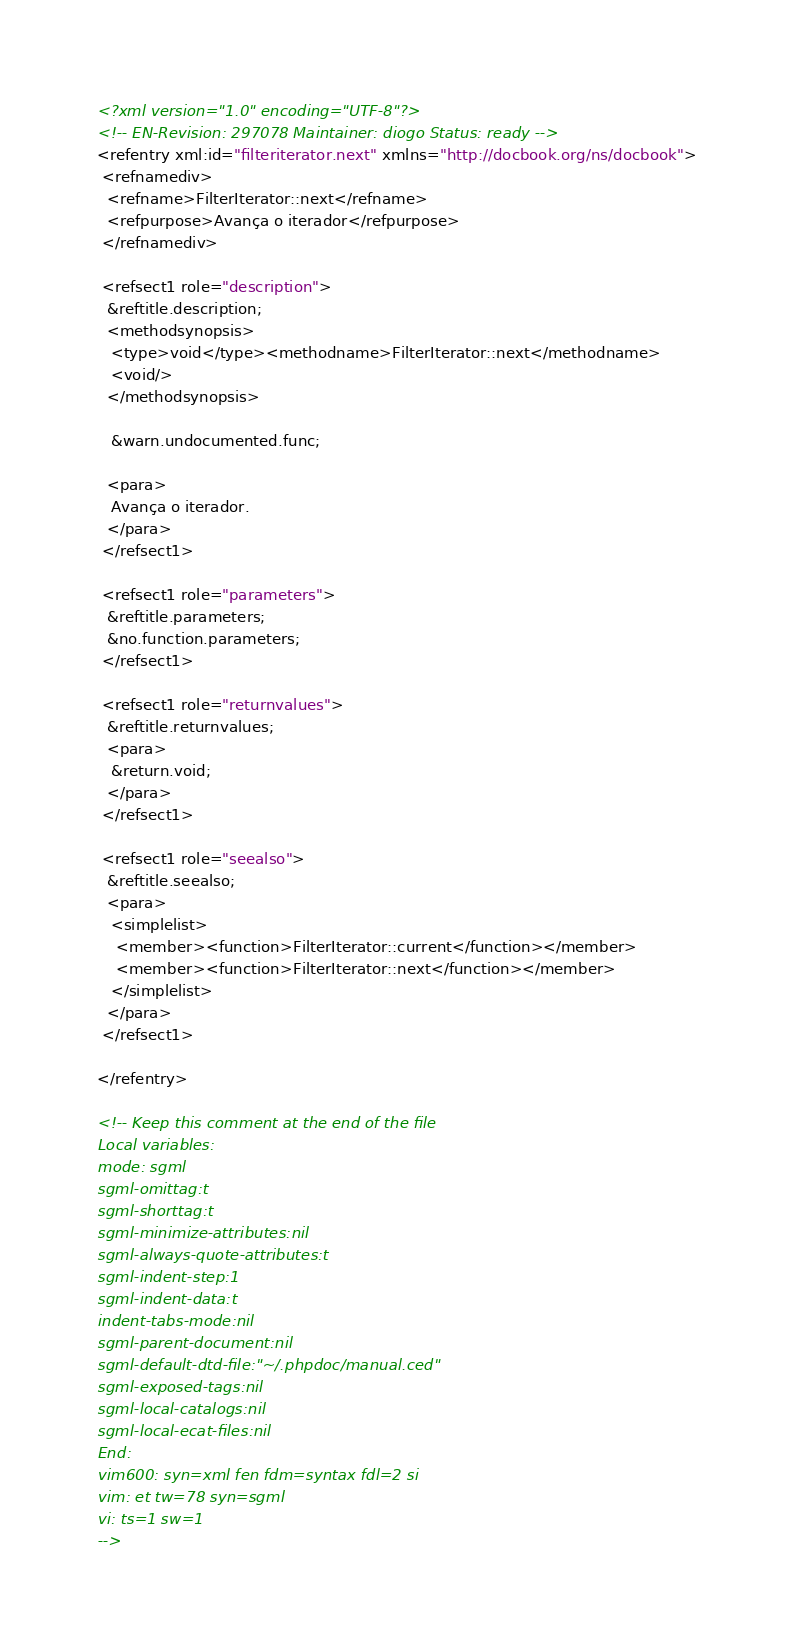Convert code to text. <code><loc_0><loc_0><loc_500><loc_500><_XML_><?xml version="1.0" encoding="UTF-8"?>
<!-- EN-Revision: 297078 Maintainer: diogo Status: ready -->
<refentry xml:id="filteriterator.next" xmlns="http://docbook.org/ns/docbook">
 <refnamediv>
  <refname>FilterIterator::next</refname>
  <refpurpose>Avança o iterador</refpurpose>
 </refnamediv>

 <refsect1 role="description">
  &reftitle.description;
  <methodsynopsis>
   <type>void</type><methodname>FilterIterator::next</methodname>
   <void/>
  </methodsynopsis>

   &warn.undocumented.func;

  <para>
   Avança o iterador.
  </para>
 </refsect1>

 <refsect1 role="parameters">
  &reftitle.parameters;
  &no.function.parameters;
 </refsect1>

 <refsect1 role="returnvalues">
  &reftitle.returnvalues;
  <para>
   &return.void;
  </para>
 </refsect1>

 <refsect1 role="seealso">
  &reftitle.seealso;
  <para>
   <simplelist>
    <member><function>FilterIterator::current</function></member>
    <member><function>FilterIterator::next</function></member>
   </simplelist>
  </para>
 </refsect1>

</refentry>

<!-- Keep this comment at the end of the file
Local variables:
mode: sgml
sgml-omittag:t
sgml-shorttag:t
sgml-minimize-attributes:nil
sgml-always-quote-attributes:t
sgml-indent-step:1
sgml-indent-data:t
indent-tabs-mode:nil
sgml-parent-document:nil
sgml-default-dtd-file:"~/.phpdoc/manual.ced"
sgml-exposed-tags:nil
sgml-local-catalogs:nil
sgml-local-ecat-files:nil
End:
vim600: syn=xml fen fdm=syntax fdl=2 si
vim: et tw=78 syn=sgml
vi: ts=1 sw=1
-->
</code> 